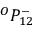<formula> <loc_0><loc_0><loc_500><loc_500>{ } ^ { O } { P } _ { 1 { 2 } } ^ { - }</formula> 